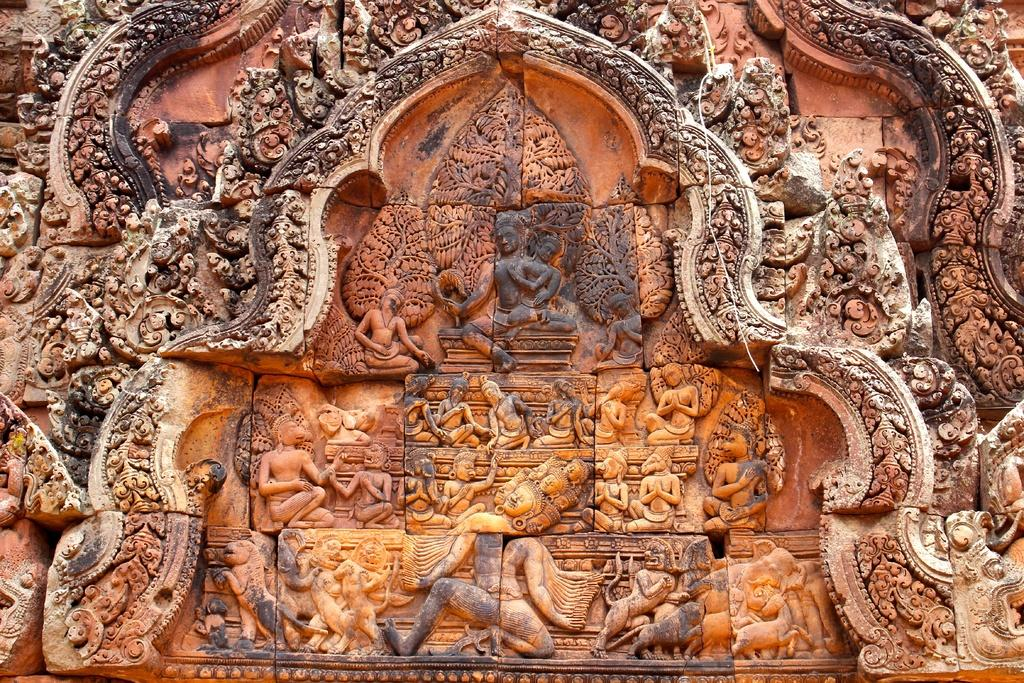What is present on the wall in the image? There are sculptures on a wall in the image. What else can be seen on the wall in the image? There are different designs on the wall in the image. What type of quilt is draped over the sculptures in the image? There is no quilt present in the image; it only features sculptures and designs on the wall. Can you see any bats hanging from the sculptures in the image? There are no bats present in the image. 